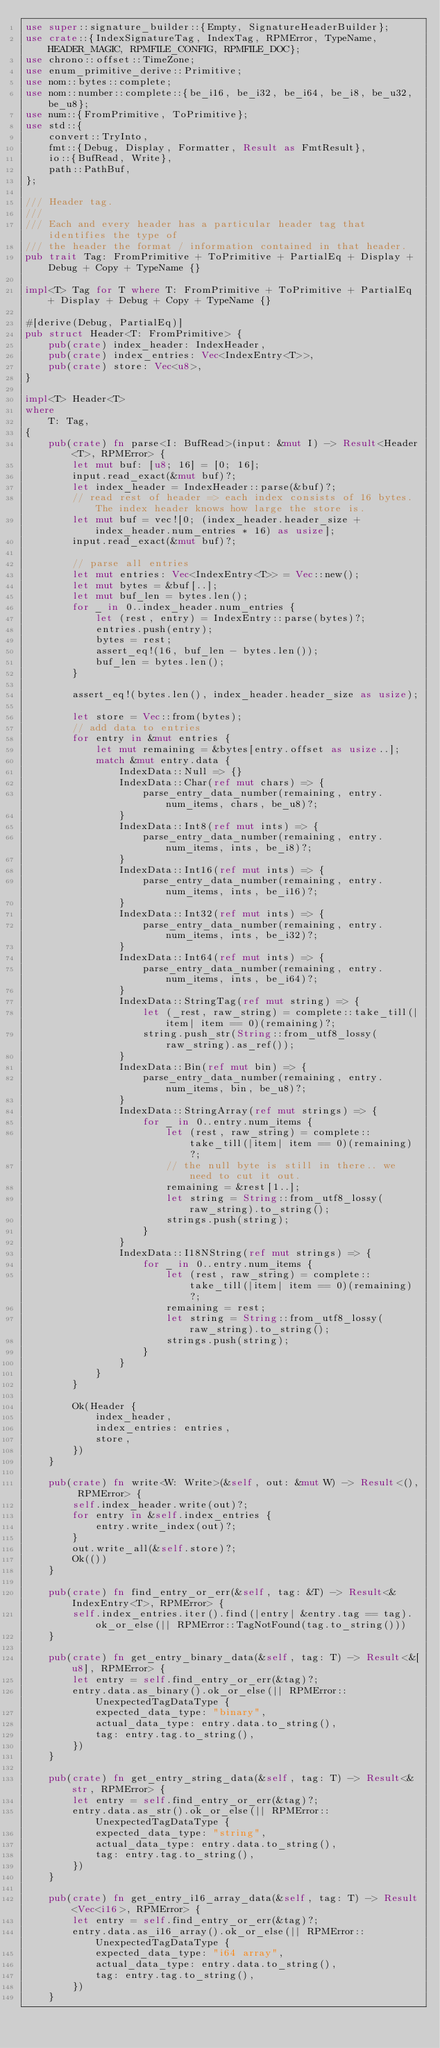Convert code to text. <code><loc_0><loc_0><loc_500><loc_500><_Rust_>use super::signature_builder::{Empty, SignatureHeaderBuilder};
use crate::{IndexSignatureTag, IndexTag, RPMError, TypeName, HEADER_MAGIC, RPMFILE_CONFIG, RPMFILE_DOC};
use chrono::offset::TimeZone;
use enum_primitive_derive::Primitive;
use nom::bytes::complete;
use nom::number::complete::{be_i16, be_i32, be_i64, be_i8, be_u32, be_u8};
use num::{FromPrimitive, ToPrimitive};
use std::{
    convert::TryInto,
    fmt::{Debug, Display, Formatter, Result as FmtResult},
    io::{BufRead, Write},
    path::PathBuf,
};

/// Header tag.
///
/// Each and every header has a particular header tag that identifies the type of
/// the header the format / information contained in that header.
pub trait Tag: FromPrimitive + ToPrimitive + PartialEq + Display + Debug + Copy + TypeName {}

impl<T> Tag for T where T: FromPrimitive + ToPrimitive + PartialEq + Display + Debug + Copy + TypeName {}

#[derive(Debug, PartialEq)]
pub struct Header<T: FromPrimitive> {
    pub(crate) index_header: IndexHeader,
    pub(crate) index_entries: Vec<IndexEntry<T>>,
    pub(crate) store: Vec<u8>,
}

impl<T> Header<T>
where
    T: Tag,
{
    pub(crate) fn parse<I: BufRead>(input: &mut I) -> Result<Header<T>, RPMError> {
        let mut buf: [u8; 16] = [0; 16];
        input.read_exact(&mut buf)?;
        let index_header = IndexHeader::parse(&buf)?;
        // read rest of header => each index consists of 16 bytes. The index header knows how large the store is.
        let mut buf = vec![0; (index_header.header_size + index_header.num_entries * 16) as usize];
        input.read_exact(&mut buf)?;

        // parse all entries
        let mut entries: Vec<IndexEntry<T>> = Vec::new();
        let mut bytes = &buf[..];
        let mut buf_len = bytes.len();
        for _ in 0..index_header.num_entries {
            let (rest, entry) = IndexEntry::parse(bytes)?;
            entries.push(entry);
            bytes = rest;
            assert_eq!(16, buf_len - bytes.len());
            buf_len = bytes.len();
        }

        assert_eq!(bytes.len(), index_header.header_size as usize);

        let store = Vec::from(bytes);
        // add data to entries
        for entry in &mut entries {
            let mut remaining = &bytes[entry.offset as usize..];
            match &mut entry.data {
                IndexData::Null => {}
                IndexData::Char(ref mut chars) => {
                    parse_entry_data_number(remaining, entry.num_items, chars, be_u8)?;
                }
                IndexData::Int8(ref mut ints) => {
                    parse_entry_data_number(remaining, entry.num_items, ints, be_i8)?;
                }
                IndexData::Int16(ref mut ints) => {
                    parse_entry_data_number(remaining, entry.num_items, ints, be_i16)?;
                }
                IndexData::Int32(ref mut ints) => {
                    parse_entry_data_number(remaining, entry.num_items, ints, be_i32)?;
                }
                IndexData::Int64(ref mut ints) => {
                    parse_entry_data_number(remaining, entry.num_items, ints, be_i64)?;
                }
                IndexData::StringTag(ref mut string) => {
                    let (_rest, raw_string) = complete::take_till(|item| item == 0)(remaining)?;
                    string.push_str(String::from_utf8_lossy(raw_string).as_ref());
                }
                IndexData::Bin(ref mut bin) => {
                    parse_entry_data_number(remaining, entry.num_items, bin, be_u8)?;
                }
                IndexData::StringArray(ref mut strings) => {
                    for _ in 0..entry.num_items {
                        let (rest, raw_string) = complete::take_till(|item| item == 0)(remaining)?;
                        // the null byte is still in there.. we need to cut it out.
                        remaining = &rest[1..];
                        let string = String::from_utf8_lossy(raw_string).to_string();
                        strings.push(string);
                    }
                }
                IndexData::I18NString(ref mut strings) => {
                    for _ in 0..entry.num_items {
                        let (rest, raw_string) = complete::take_till(|item| item == 0)(remaining)?;
                        remaining = rest;
                        let string = String::from_utf8_lossy(raw_string).to_string();
                        strings.push(string);
                    }
                }
            }
        }

        Ok(Header {
            index_header,
            index_entries: entries,
            store,
        })
    }

    pub(crate) fn write<W: Write>(&self, out: &mut W) -> Result<(), RPMError> {
        self.index_header.write(out)?;
        for entry in &self.index_entries {
            entry.write_index(out)?;
        }
        out.write_all(&self.store)?;
        Ok(())
    }

    pub(crate) fn find_entry_or_err(&self, tag: &T) -> Result<&IndexEntry<T>, RPMError> {
        self.index_entries.iter().find(|entry| &entry.tag == tag).ok_or_else(|| RPMError::TagNotFound(tag.to_string()))
    }

    pub(crate) fn get_entry_binary_data(&self, tag: T) -> Result<&[u8], RPMError> {
        let entry = self.find_entry_or_err(&tag)?;
        entry.data.as_binary().ok_or_else(|| RPMError::UnexpectedTagDataType {
            expected_data_type: "binary",
            actual_data_type: entry.data.to_string(),
            tag: entry.tag.to_string(),
        })
    }

    pub(crate) fn get_entry_string_data(&self, tag: T) -> Result<&str, RPMError> {
        let entry = self.find_entry_or_err(&tag)?;
        entry.data.as_str().ok_or_else(|| RPMError::UnexpectedTagDataType {
            expected_data_type: "string",
            actual_data_type: entry.data.to_string(),
            tag: entry.tag.to_string(),
        })
    }

    pub(crate) fn get_entry_i16_array_data(&self, tag: T) -> Result<Vec<i16>, RPMError> {
        let entry = self.find_entry_or_err(&tag)?;
        entry.data.as_i16_array().ok_or_else(|| RPMError::UnexpectedTagDataType {
            expected_data_type: "i64 array",
            actual_data_type: entry.data.to_string(),
            tag: entry.tag.to_string(),
        })
    }
</code> 